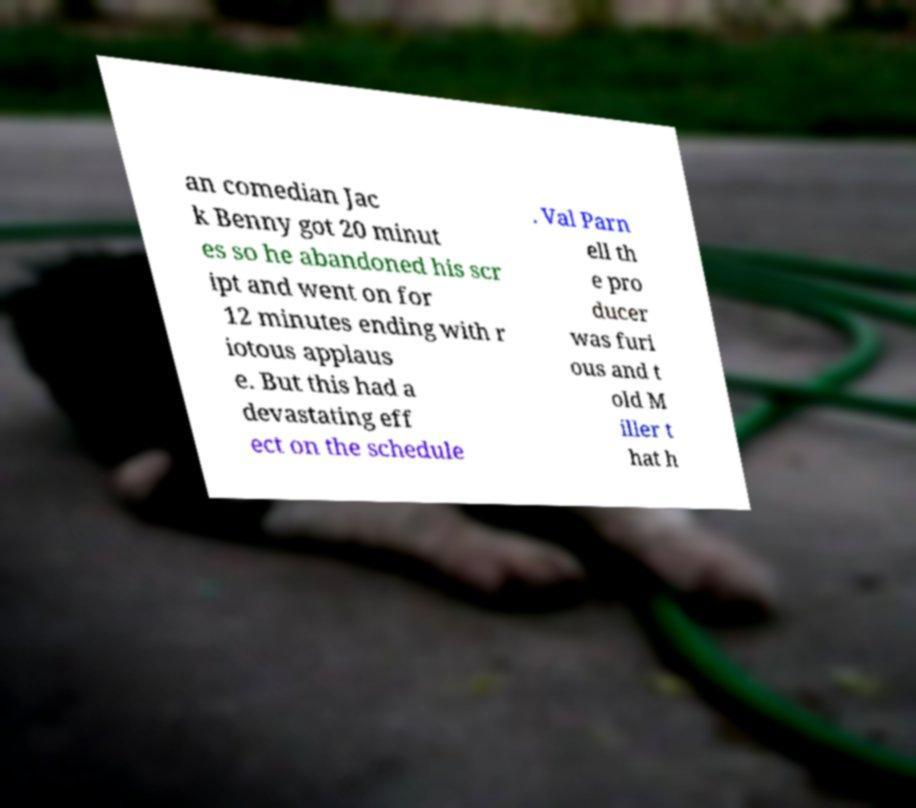For documentation purposes, I need the text within this image transcribed. Could you provide that? an comedian Jac k Benny got 20 minut es so he abandoned his scr ipt and went on for 12 minutes ending with r iotous applaus e. But this had a devastating eff ect on the schedule . Val Parn ell th e pro ducer was furi ous and t old M iller t hat h 